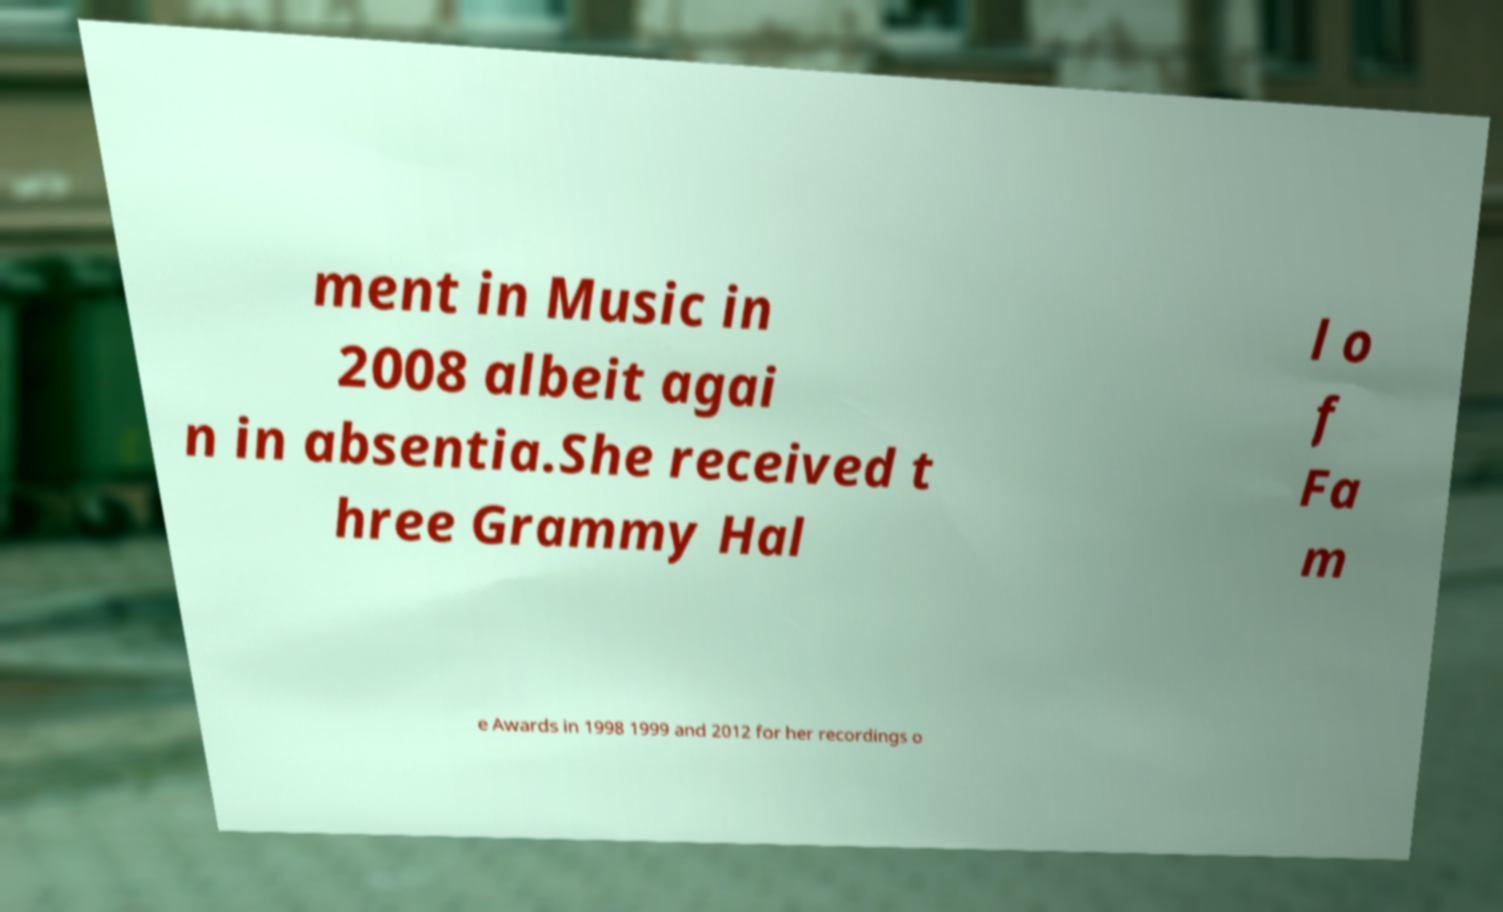Could you assist in decoding the text presented in this image and type it out clearly? ment in Music in 2008 albeit agai n in absentia.She received t hree Grammy Hal l o f Fa m e Awards in 1998 1999 and 2012 for her recordings o 